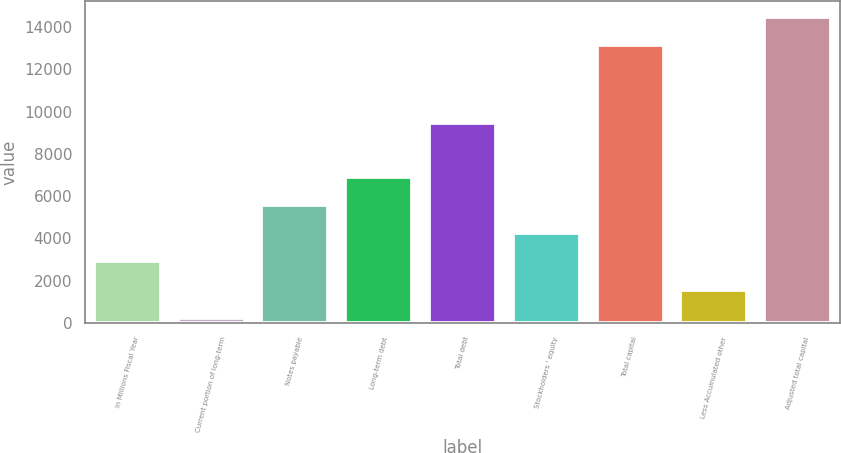Convert chart. <chart><loc_0><loc_0><loc_500><loc_500><bar_chart><fcel>In Millions Fiscal Year<fcel>Current portion of long-term<fcel>Notes payable<fcel>Long-term debt<fcel>Total debt<fcel>Stockholders ' equity<fcel>Total capital<fcel>Less Accumulated other<fcel>Adjusted total capital<nl><fcel>2907.2<fcel>248<fcel>5566.4<fcel>6896<fcel>9439<fcel>4236.8<fcel>13168<fcel>1577.6<fcel>14497.6<nl></chart> 